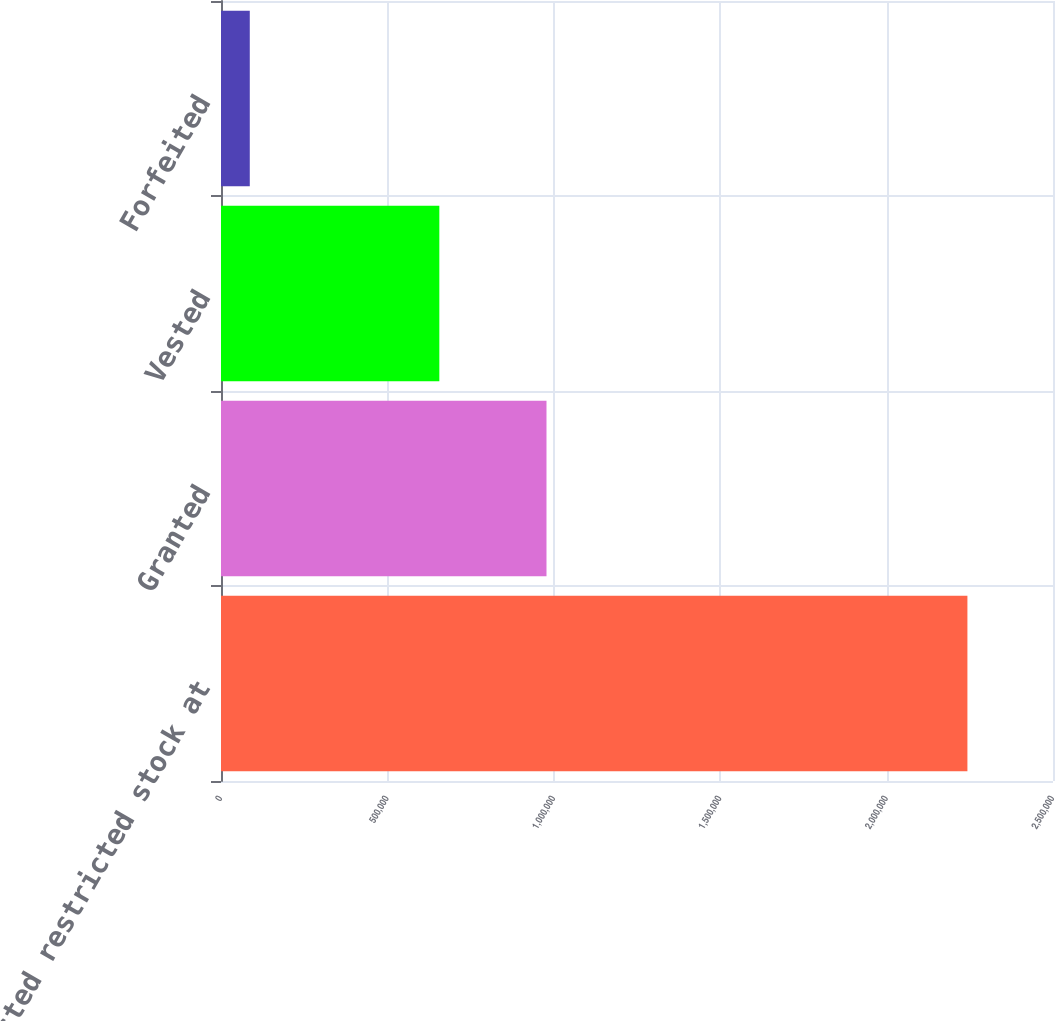Convert chart to OTSL. <chart><loc_0><loc_0><loc_500><loc_500><bar_chart><fcel>Nonvested restricted stock at<fcel>Granted<fcel>Vested<fcel>Forfeited<nl><fcel>2.24283e+06<fcel>978064<fcel>656054<fcel>86484<nl></chart> 